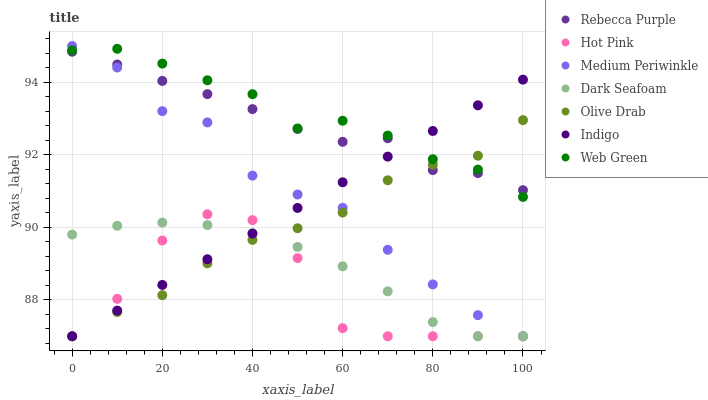Does Hot Pink have the minimum area under the curve?
Answer yes or no. Yes. Does Web Green have the maximum area under the curve?
Answer yes or no. Yes. Does Medium Periwinkle have the minimum area under the curve?
Answer yes or no. No. Does Medium Periwinkle have the maximum area under the curve?
Answer yes or no. No. Is Indigo the smoothest?
Answer yes or no. Yes. Is Hot Pink the roughest?
Answer yes or no. Yes. Is Medium Periwinkle the smoothest?
Answer yes or no. No. Is Medium Periwinkle the roughest?
Answer yes or no. No. Does Indigo have the lowest value?
Answer yes or no. Yes. Does Web Green have the lowest value?
Answer yes or no. No. Does Medium Periwinkle have the highest value?
Answer yes or no. Yes. Does Hot Pink have the highest value?
Answer yes or no. No. Is Hot Pink less than Web Green?
Answer yes or no. Yes. Is Web Green greater than Hot Pink?
Answer yes or no. Yes. Does Indigo intersect Olive Drab?
Answer yes or no. Yes. Is Indigo less than Olive Drab?
Answer yes or no. No. Is Indigo greater than Olive Drab?
Answer yes or no. No. Does Hot Pink intersect Web Green?
Answer yes or no. No. 